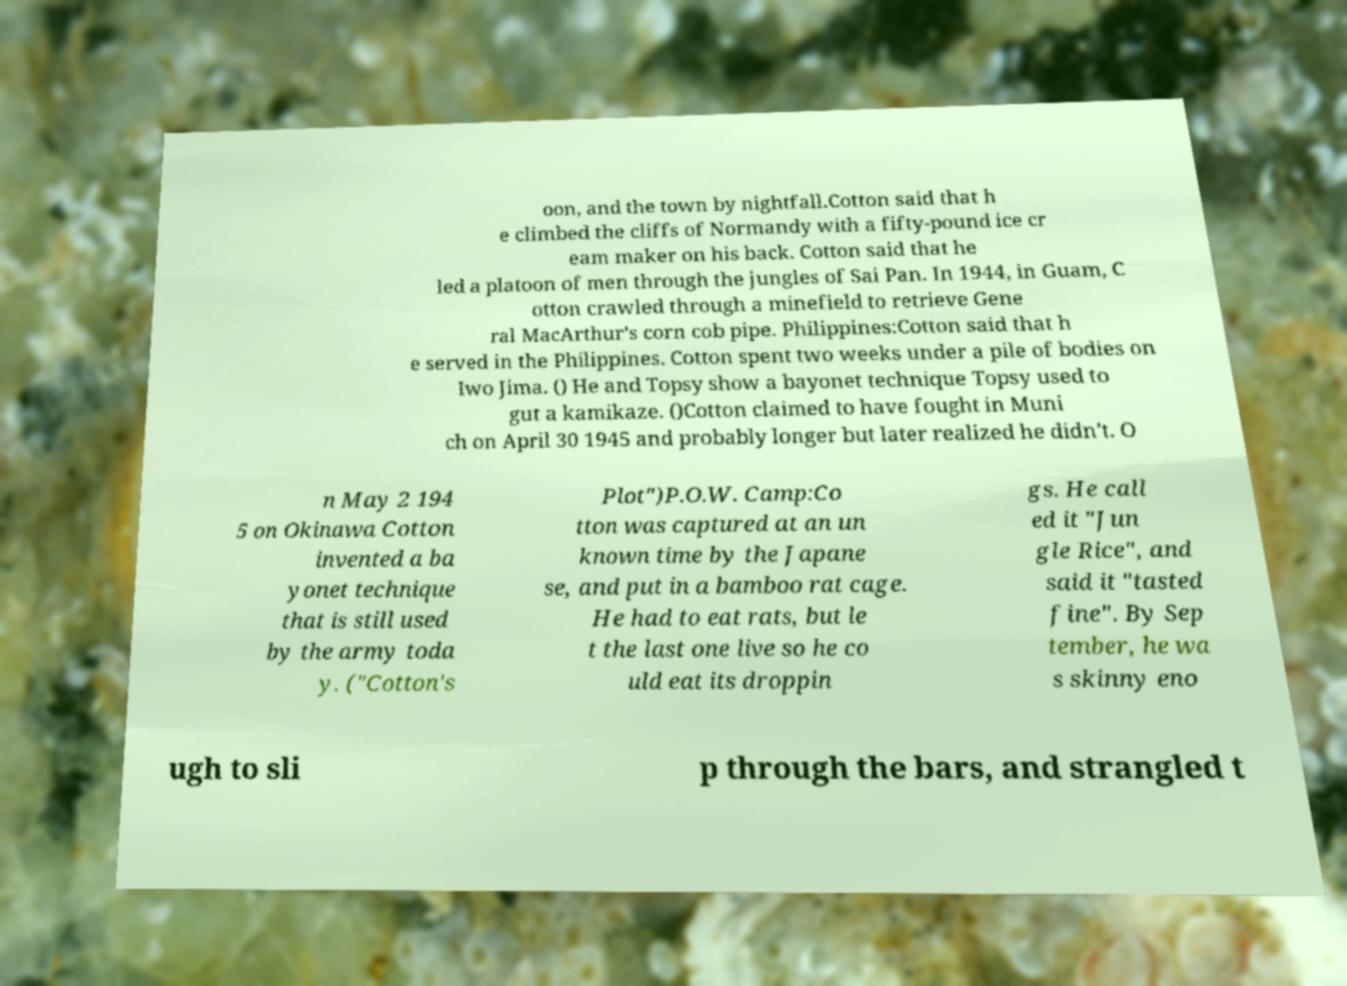There's text embedded in this image that I need extracted. Can you transcribe it verbatim? oon, and the town by nightfall.Cotton said that h e climbed the cliffs of Normandy with a fifty-pound ice cr eam maker on his back. Cotton said that he led a platoon of men through the jungles of Sai Pan. In 1944, in Guam, C otton crawled through a minefield to retrieve Gene ral MacArthur's corn cob pipe. Philippines:Cotton said that h e served in the Philippines. Cotton spent two weeks under a pile of bodies on Iwo Jima. () He and Topsy show a bayonet technique Topsy used to gut a kamikaze. ()Cotton claimed to have fought in Muni ch on April 30 1945 and probably longer but later realized he didn't. O n May 2 194 5 on Okinawa Cotton invented a ba yonet technique that is still used by the army toda y. ("Cotton's Plot")P.O.W. Camp:Co tton was captured at an un known time by the Japane se, and put in a bamboo rat cage. He had to eat rats, but le t the last one live so he co uld eat its droppin gs. He call ed it "Jun gle Rice", and said it "tasted fine". By Sep tember, he wa s skinny eno ugh to sli p through the bars, and strangled t 